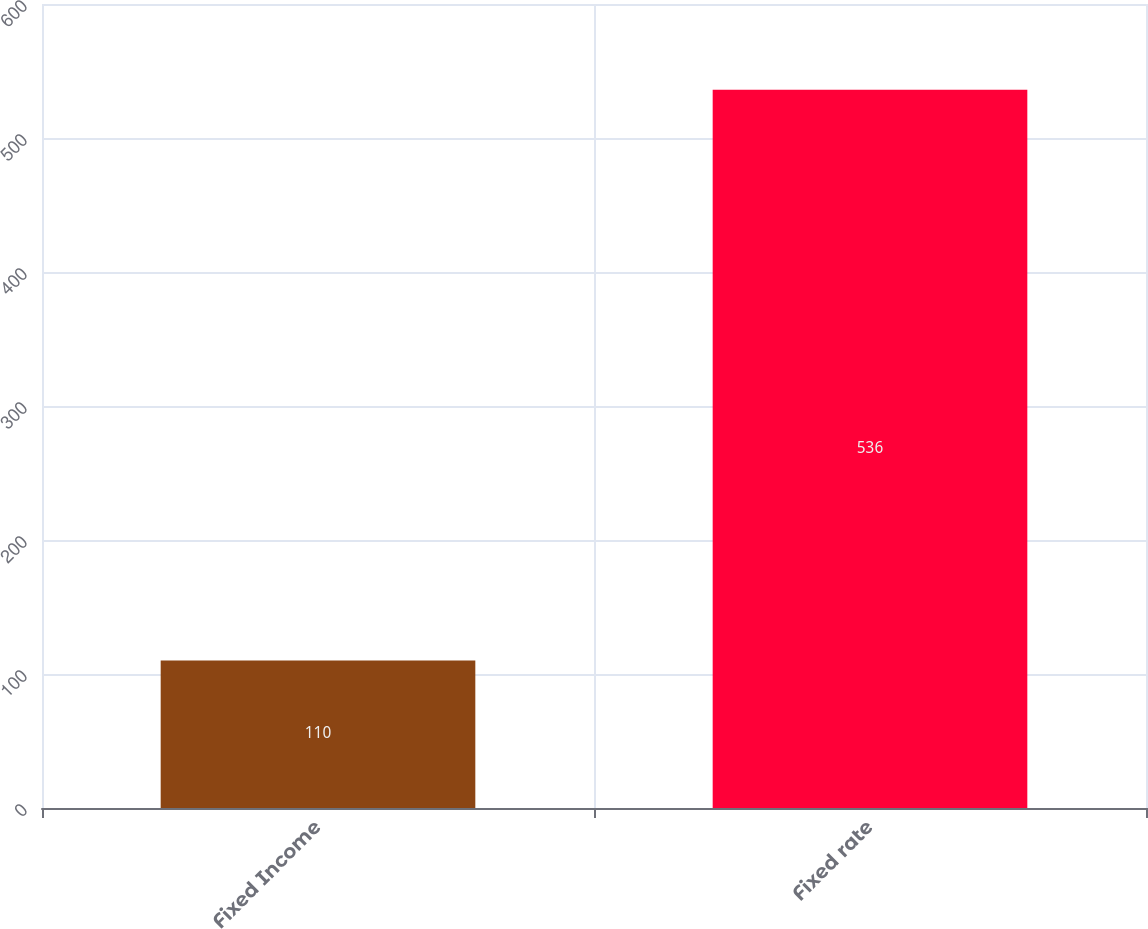Convert chart. <chart><loc_0><loc_0><loc_500><loc_500><bar_chart><fcel>Fixed Income<fcel>Fixed rate<nl><fcel>110<fcel>536<nl></chart> 